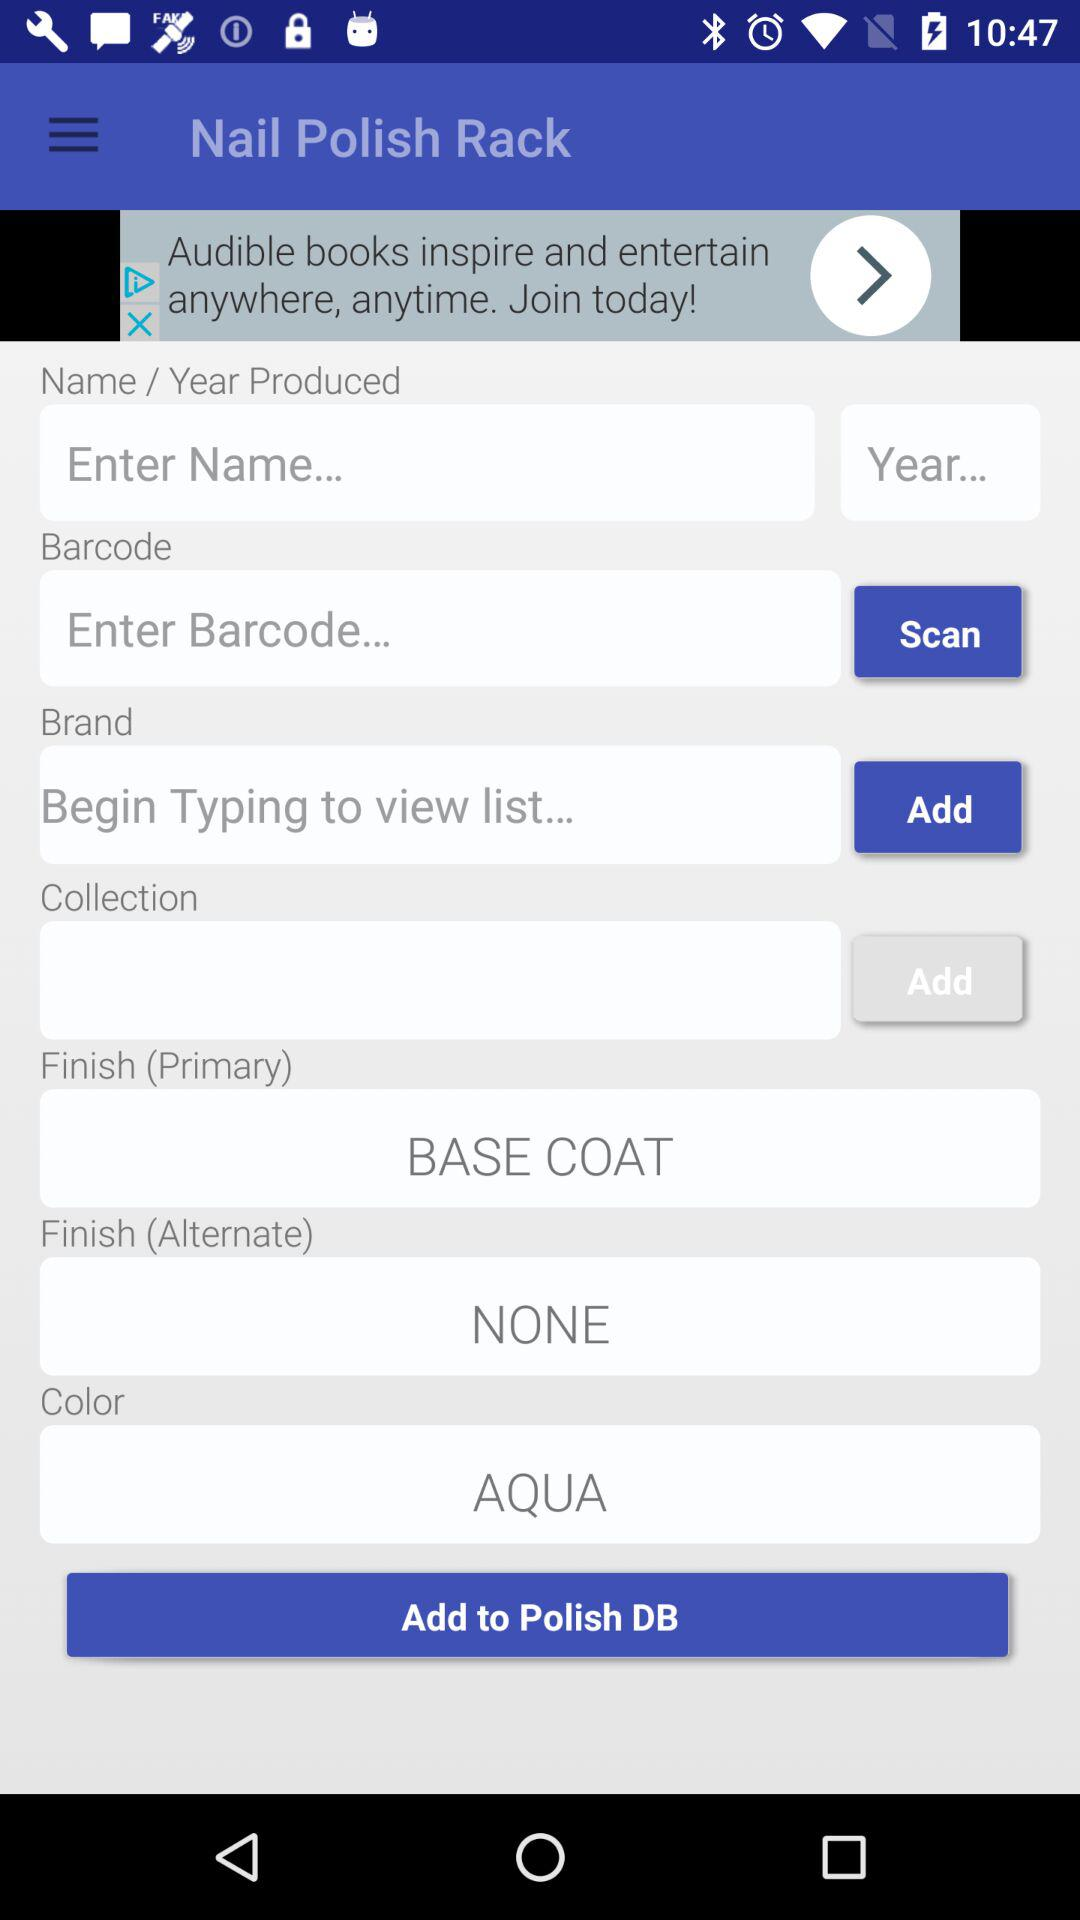What is the "Finish (Alternate)"? The "Finish (Alternate)" is none. 